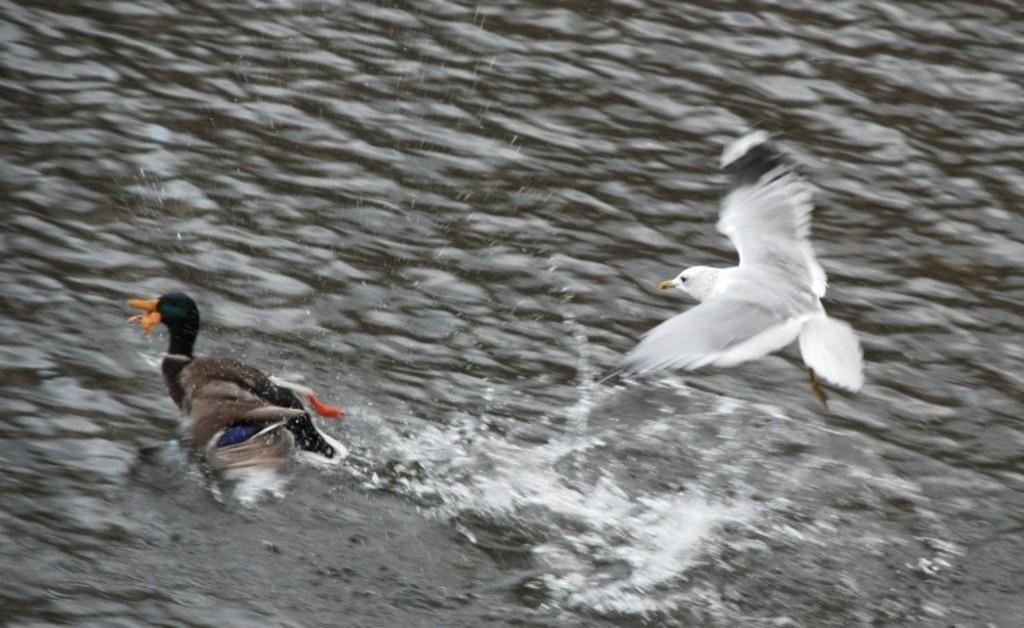What animal can be seen swimming in the water in the image? There is a duck swimming in the water in the image. What other animal can be seen in the image? There is an eagle flying in the air in the image. What is the environment like in the image? The duck and eagle are surrounded by water. What type of glue is being used by the duck in the image? There is no glue present in the image; the duck is swimming in the water. What does the eagle taste like in the image? There is no indication that the eagle is being tasted or consumed in the image; it is flying in the air. 